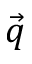<formula> <loc_0><loc_0><loc_500><loc_500>\vec { q }</formula> 